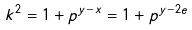<formula> <loc_0><loc_0><loc_500><loc_500>k ^ { 2 } = 1 + p ^ { y - x } = 1 + p ^ { y - 2 e }</formula> 